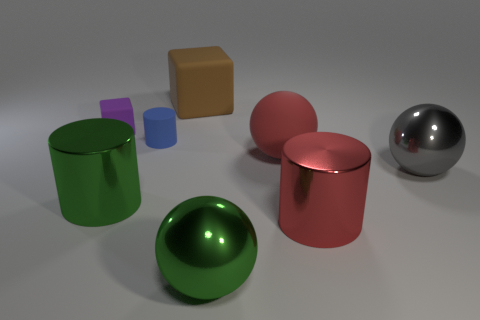What number of things are either big metallic objects on the left side of the big red cylinder or tiny blue objects?
Offer a very short reply. 3. There is a big green metallic ball that is in front of the small blue matte cylinder; what number of green objects are behind it?
Keep it short and to the point. 1. Are there fewer brown matte cubes in front of the purple thing than rubber objects that are in front of the large red cylinder?
Ensure brevity in your answer.  No. What shape is the large green thing that is in front of the big metallic thing that is to the left of the large brown rubber object?
Offer a very short reply. Sphere. What number of other objects are the same material as the blue object?
Make the answer very short. 3. Is there any other thing that is the same size as the gray thing?
Provide a short and direct response. Yes. Are there more large green shiny things than big green metallic cubes?
Ensure brevity in your answer.  Yes. There is a thing in front of the metallic cylinder right of the object in front of the red cylinder; what size is it?
Offer a terse response. Large. Is the size of the gray shiny object the same as the block to the left of the green metal cylinder?
Provide a short and direct response. No. Is the number of gray things that are to the left of the large block less than the number of brown cubes?
Ensure brevity in your answer.  Yes. 